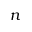Convert formula to latex. <formula><loc_0><loc_0><loc_500><loc_500>n</formula> 